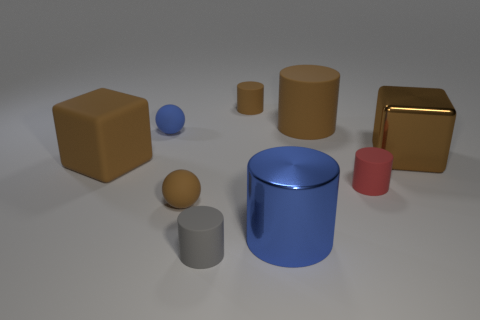The blue thing that is the same size as the rubber cube is what shape?
Offer a terse response. Cylinder. What number of brown objects are either rubber cubes or big cubes?
Your answer should be compact. 2. What number of other brown matte blocks have the same size as the rubber block?
Keep it short and to the point. 0. There is a large metal object that is the same color as the large rubber cube; what shape is it?
Your answer should be compact. Cube. How many objects are tiny brown matte balls or tiny brown matte things on the left side of the small gray object?
Keep it short and to the point. 1. Do the brown rubber block behind the small red cylinder and the brown object to the right of the large rubber cylinder have the same size?
Give a very brief answer. Yes. What number of other objects are the same shape as the blue rubber thing?
Ensure brevity in your answer.  1. The small gray object that is the same material as the red object is what shape?
Your response must be concise. Cylinder. What material is the big brown object that is to the right of the small matte thing that is right of the tiny matte cylinder behind the tiny blue sphere?
Provide a succinct answer. Metal. There is a gray matte cylinder; does it have the same size as the brown thing that is right of the red matte object?
Ensure brevity in your answer.  No. 